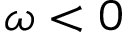Convert formula to latex. <formula><loc_0><loc_0><loc_500><loc_500>\omega < 0</formula> 